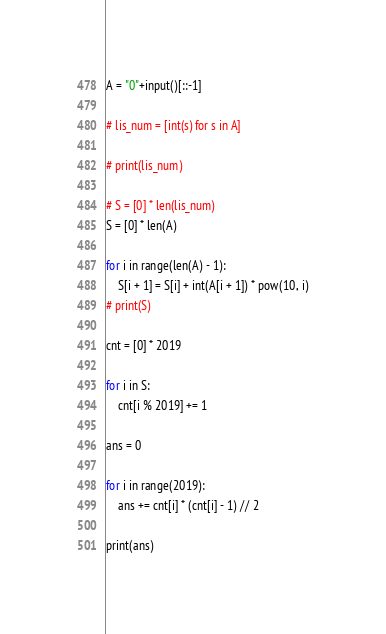<code> <loc_0><loc_0><loc_500><loc_500><_Python_>A = "0"+input()[::-1]

# lis_num = [int(s) for s in A]

# print(lis_num)

# S = [0] * len(lis_num)
S = [0] * len(A)

for i in range(len(A) - 1):
    S[i + 1] = S[i] + int(A[i + 1]) * pow(10, i)
# print(S)

cnt = [0] * 2019

for i in S:
    cnt[i % 2019] += 1

ans = 0

for i in range(2019):
    ans += cnt[i] * (cnt[i] - 1) // 2

print(ans)
</code> 